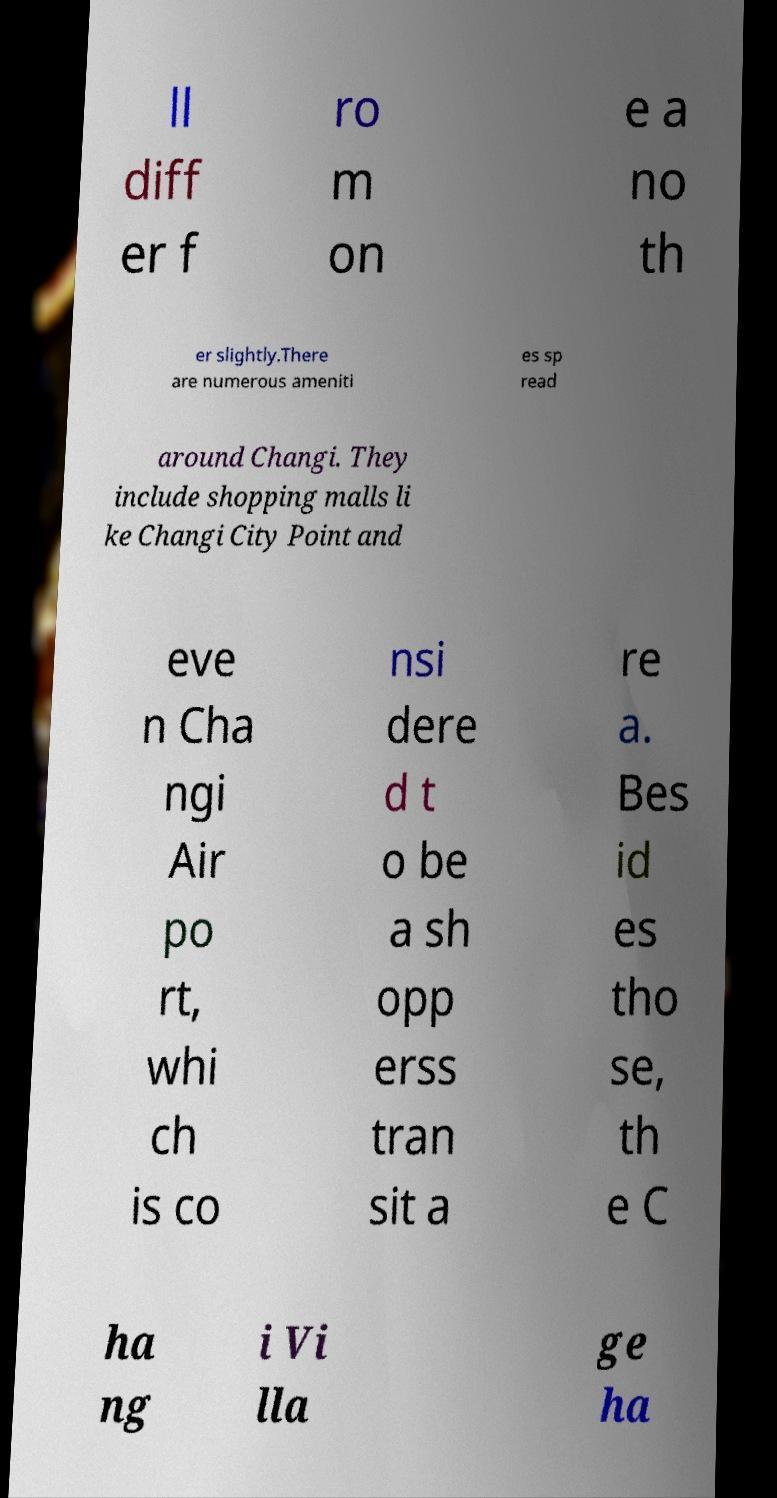Please identify and transcribe the text found in this image. ll diff er f ro m on e a no th er slightly.There are numerous ameniti es sp read around Changi. They include shopping malls li ke Changi City Point and eve n Cha ngi Air po rt, whi ch is co nsi dere d t o be a sh opp erss tran sit a re a. Bes id es tho se, th e C ha ng i Vi lla ge ha 